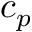<formula> <loc_0><loc_0><loc_500><loc_500>c _ { p }</formula> 